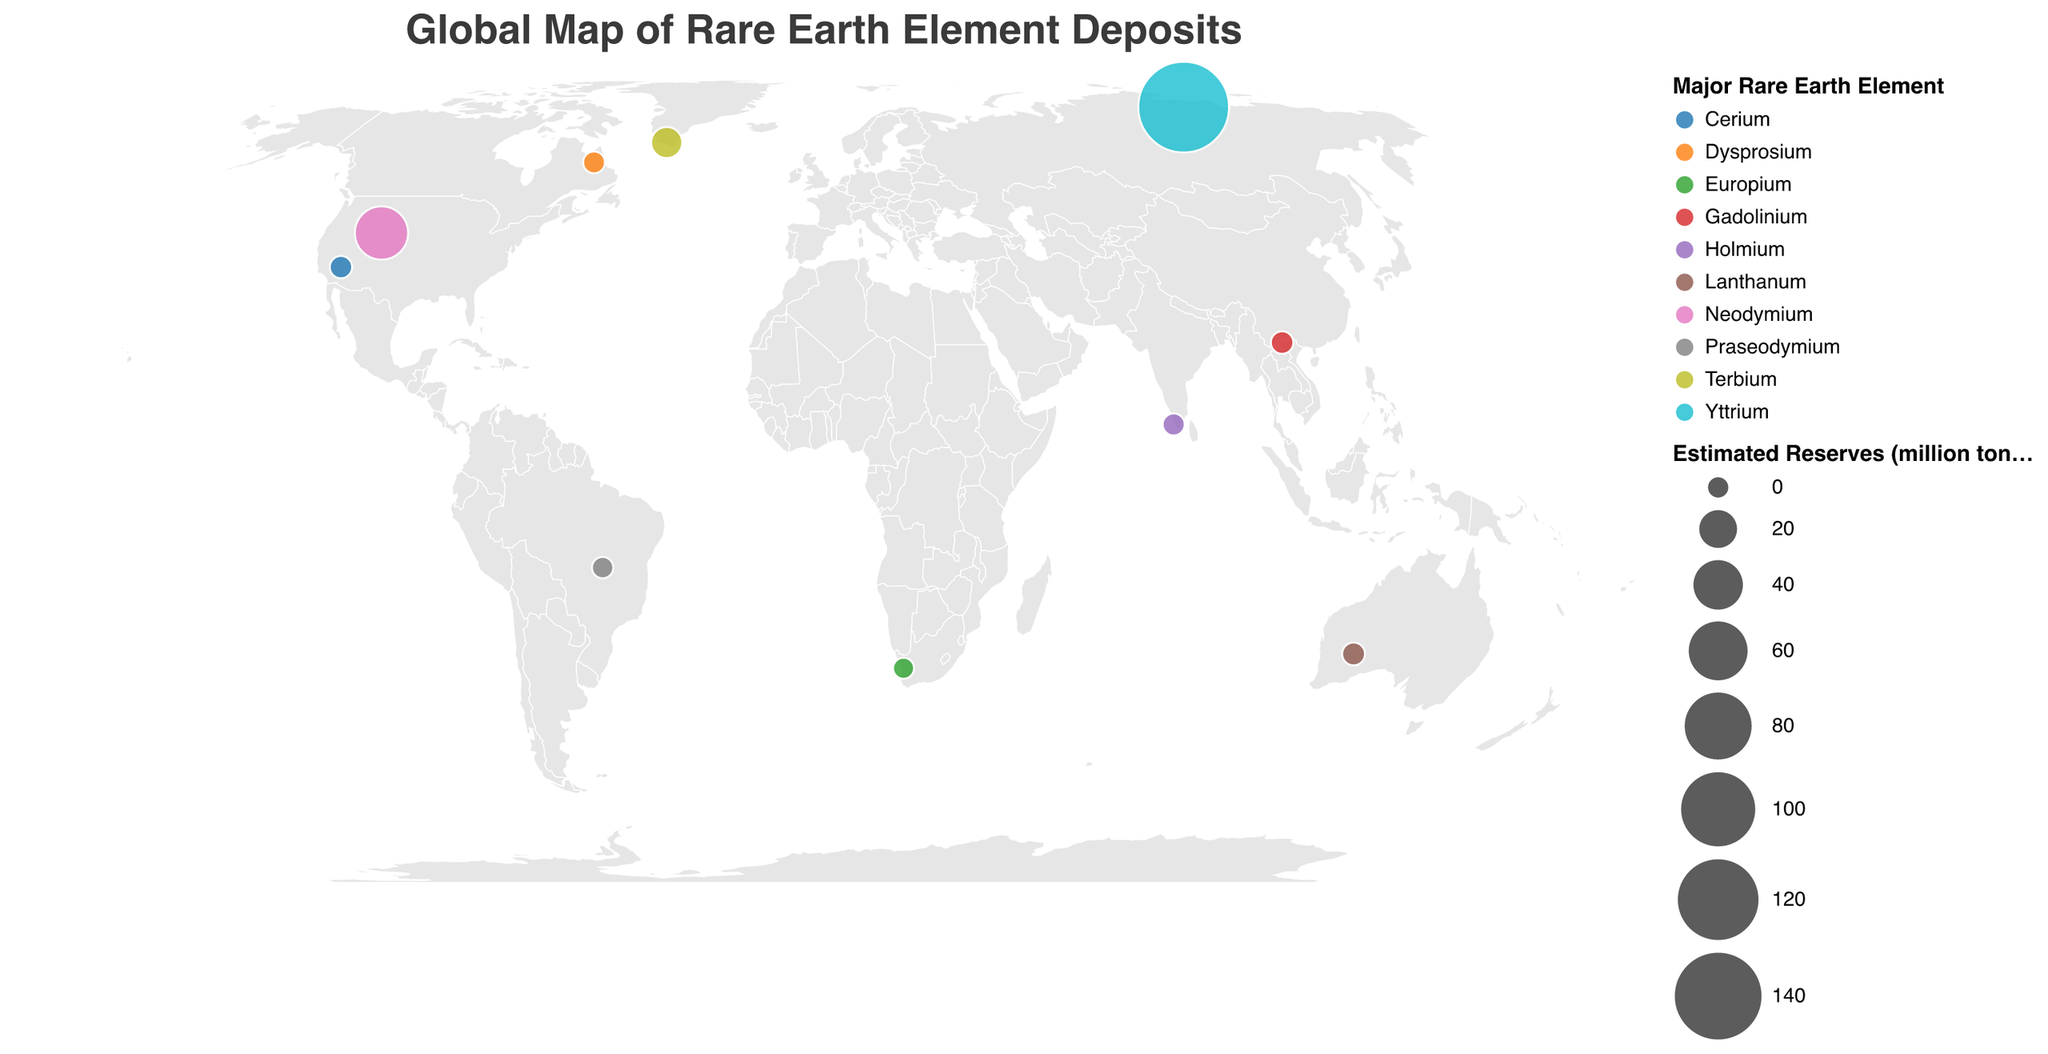What is the major rare earth element found in the Bayan Obo deposit in China? The tooltip in the figure shows that the Bayan Obo deposit in China primarily contains Neodymium.
Answer: Neodymium Which country has the deposit with the highest estimated reserves? By comparing the sizes of the circles, the largest circle corresponds to the Tomtor deposit in Russia, which has the highest estimated reserves of 154 million tonnes.
Answer: Russia How many deposits have estimated reserves greater than 10 million tonnes? From the circle sizes and the tooltips, we can identify two deposits: Bayan Obo (48 million tonnes) and Tomtor (154 million tonnes).
Answer: 2 What are the estimated reserves of the Mountain Pass deposit in the USA? The tooltip for the Mountain Pass deposit in the USA shows an estimated reserve of 1.8 million tonnes.
Answer: 1.8 million tonnes Which deposit has Terbium as the major rare earth element? The tooltip for the Kvanefjeld deposit in Greenland shows that its major rare earth element is Terbium.
Answer: Kvanefjeld (Greenland) What is the total estimated reserves of deposits located in the Southern Hemisphere? The deposits in the Southern Hemisphere are Mount Weld (2.2), Serra Verde (0.9), Steenkampskraal (0.6). Summing these gives 2.2 + 0.9 + 0.6 = 3.7 million tonnes.
Answer: 3.7 million tonnes Compare the estimated reserves of Mount Weld in Australia and Mountain Pass in the USA. Which one is higher? The tooltip shows that Mount Weld has 2.2 million tonnes of estimated reserves, while Mountain Pass has 1.8 million tonnes. Therefore, Mount Weld has higher reserves.
Answer: Mount Weld What is the latitude and longitude of the deposit with Dysprosium as the major rare earth element? The tooltip indicates that the deposit with Dysprosium is Strange Lake in Canada, located at latitude 56.3 and longitude -64.1.
Answer: Latitude 56.3, Longitude -64.1 Which deposit in the dataset has the smallest estimated reserves? By comparing the circle sizes and checking the tooltips, Steenkampskraal in South Africa has the smallest estimated reserves at 0.6 million tonnes.
Answer: Steenkampskraal 